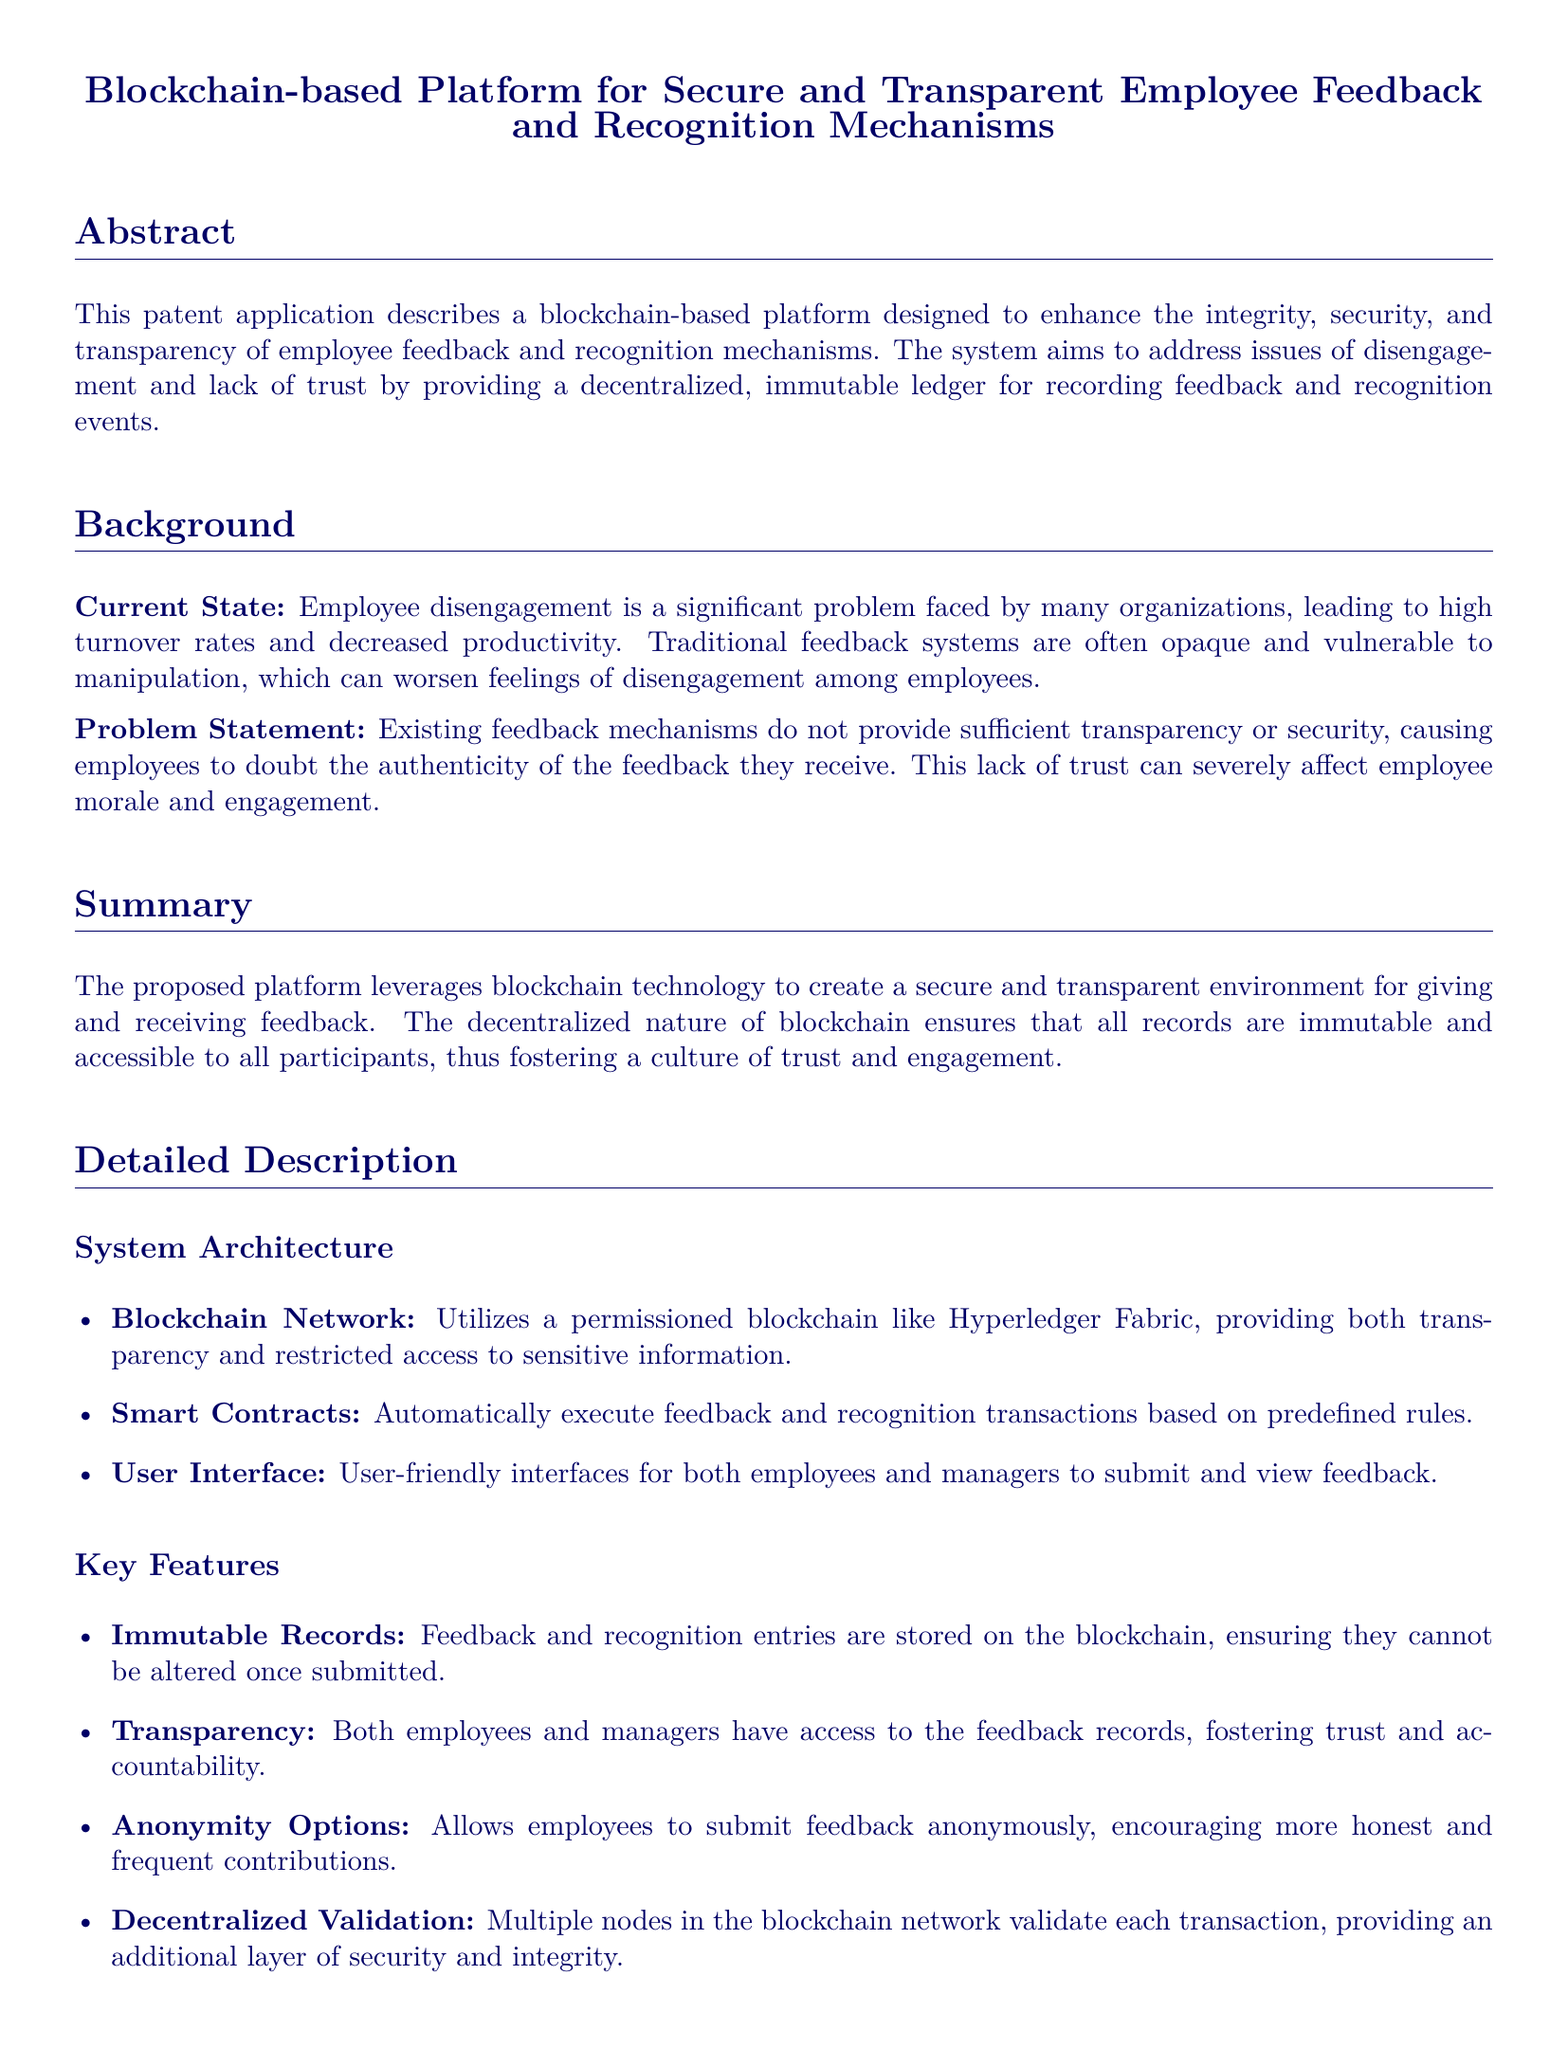What is the title of the patent application? The title gives a brief overview of the invention and its purpose.
Answer: Blockchain-based Platform for Secure and Transparent Employee Feedback and Recognition Mechanisms What problem does the platform aim to address? The problem statement outlines the main issue that the invention seeks to solve.
Answer: Employee disengagement Which blockchain technology is suggested for the platform? The system architecture section mentions the technology used for the blockchain.
Answer: Hyperledger Fabric What is one key feature of the proposed platform? The key features list identifies distinct characteristics of the platform.
Answer: Immutable Records What benefit does the platform provide for HR Departments? The benefits section describes advantages for various stakeholders.
Answer: Streamlined processes How are feedback records stored? The document specifies how feedback is managed within the system.
Answer: On the blockchain What type of blockchain network is utilized? The system architecture section specifies the type of blockchain network implemented.
Answer: Permissioned blockchain What does the platform allow regarding employee feedback? The detailed description covers options available to employees for giving feedback.
Answer: Anonymity Options 